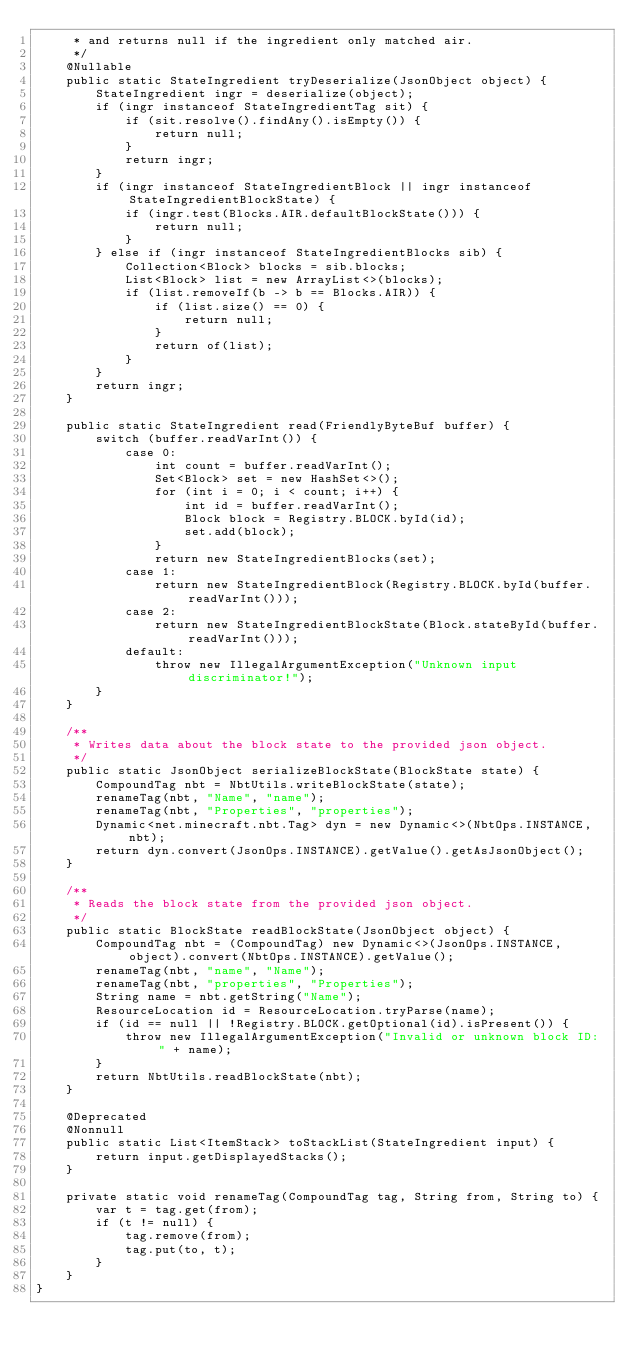<code> <loc_0><loc_0><loc_500><loc_500><_Java_>     * and returns null if the ingredient only matched air.
     */
    @Nullable
    public static StateIngredient tryDeserialize(JsonObject object) {
        StateIngredient ingr = deserialize(object);
        if (ingr instanceof StateIngredientTag sit) {
            if (sit.resolve().findAny().isEmpty()) {
                return null;
            }
            return ingr;
        }
        if (ingr instanceof StateIngredientBlock || ingr instanceof StateIngredientBlockState) {
            if (ingr.test(Blocks.AIR.defaultBlockState())) {
                return null;
            }
        } else if (ingr instanceof StateIngredientBlocks sib) {
            Collection<Block> blocks = sib.blocks;
            List<Block> list = new ArrayList<>(blocks);
            if (list.removeIf(b -> b == Blocks.AIR)) {
                if (list.size() == 0) {
                    return null;
                }
                return of(list);
            }
        }
        return ingr;
    }

    public static StateIngredient read(FriendlyByteBuf buffer) {
        switch (buffer.readVarInt()) {
            case 0:
                int count = buffer.readVarInt();
                Set<Block> set = new HashSet<>();
                for (int i = 0; i < count; i++) {
                    int id = buffer.readVarInt();
                    Block block = Registry.BLOCK.byId(id);
                    set.add(block);
                }
                return new StateIngredientBlocks(set);
            case 1:
                return new StateIngredientBlock(Registry.BLOCK.byId(buffer.readVarInt()));
            case 2:
                return new StateIngredientBlockState(Block.stateById(buffer.readVarInt()));
            default:
                throw new IllegalArgumentException("Unknown input discriminator!");
        }
    }

    /**
     * Writes data about the block state to the provided json object.
     */
    public static JsonObject serializeBlockState(BlockState state) {
        CompoundTag nbt = NbtUtils.writeBlockState(state);
        renameTag(nbt, "Name", "name");
        renameTag(nbt, "Properties", "properties");
        Dynamic<net.minecraft.nbt.Tag> dyn = new Dynamic<>(NbtOps.INSTANCE, nbt);
        return dyn.convert(JsonOps.INSTANCE).getValue().getAsJsonObject();
    }

    /**
     * Reads the block state from the provided json object.
     */
    public static BlockState readBlockState(JsonObject object) {
        CompoundTag nbt = (CompoundTag) new Dynamic<>(JsonOps.INSTANCE, object).convert(NbtOps.INSTANCE).getValue();
        renameTag(nbt, "name", "Name");
        renameTag(nbt, "properties", "Properties");
        String name = nbt.getString("Name");
        ResourceLocation id = ResourceLocation.tryParse(name);
        if (id == null || !Registry.BLOCK.getOptional(id).isPresent()) {
            throw new IllegalArgumentException("Invalid or unknown block ID: " + name);
        }
        return NbtUtils.readBlockState(nbt);
    }

    @Deprecated
    @Nonnull
    public static List<ItemStack> toStackList(StateIngredient input) {
        return input.getDisplayedStacks();
    }

    private static void renameTag(CompoundTag tag, String from, String to) {
        var t = tag.get(from);
        if (t != null) {
            tag.remove(from);
            tag.put(to, t);
        }
    }
}</code> 